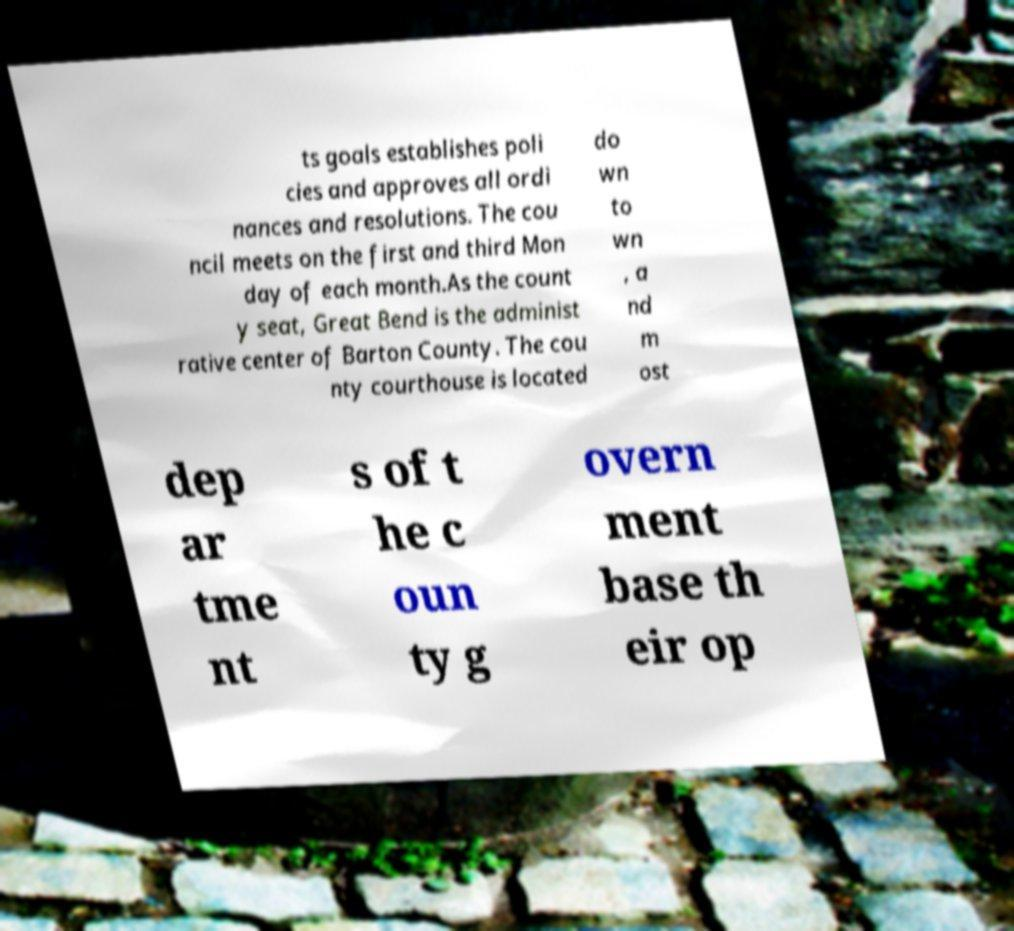What messages or text are displayed in this image? I need them in a readable, typed format. ts goals establishes poli cies and approves all ordi nances and resolutions. The cou ncil meets on the first and third Mon day of each month.As the count y seat, Great Bend is the administ rative center of Barton County. The cou nty courthouse is located do wn to wn , a nd m ost dep ar tme nt s of t he c oun ty g overn ment base th eir op 